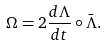<formula> <loc_0><loc_0><loc_500><loc_500>\Omega = 2 \frac { d \Lambda } { d t } \circ \bar { \Lambda } .</formula> 